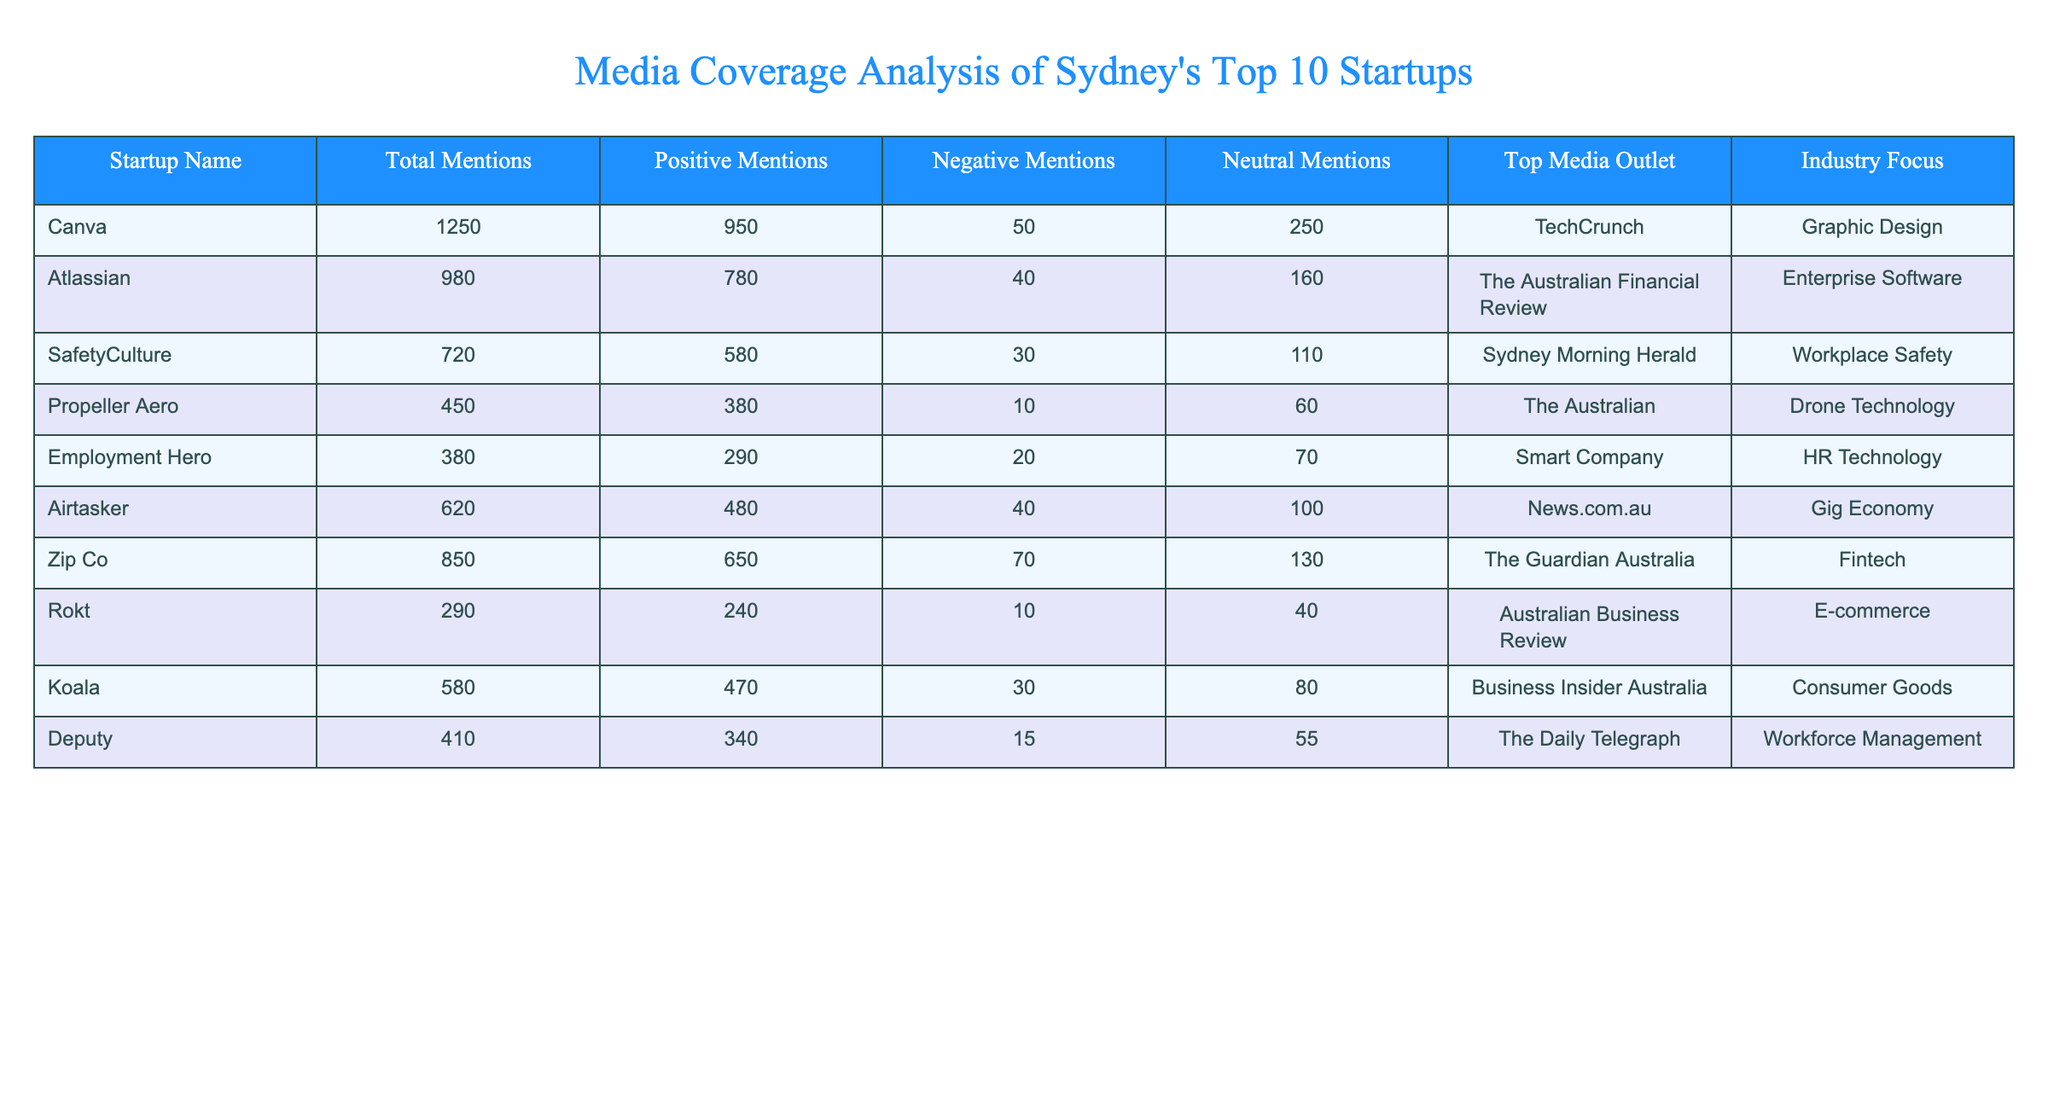What is the total number of mentions for Canva? The table shows that Canva has a total of 1250 mentions listed under the "Total Mentions" column.
Answer: 1250 Which startup has the highest number of positive mentions? By looking at the "Positive Mentions" column, Canva has the highest number at 950, compared to the others.
Answer: Canva What percentage of mentions for Zip Co are positive? The positive mentions for Zip Co are 650 out of a total of 850 mentions, which means (650/850) * 100 = 76.47%.
Answer: 76.47% Is there any startup that has more negative mentions than Deputy? Deputy has 15 negative mentions, and comparing this with other startups, only SafetyCulture (30), Employment Hero (20), Airtasker (40), and Atlassian (40) have more negative mentions. Therefore, yes, there are startups with more negative mentions.
Answer: Yes What is the average number of total mentions for the startups listed in the table? Total mentions for the startups are 1250 + 980 + 720 + 450 + 380 + 620 + 850 + 290 + 580 + 410 =  3,314 mentions; divided by 10 startups gives an average: 3,314 / 10 = 331.4.
Answer: 331.4 How many startups have more than 500 total mentions? From the table, the startups with over 500 mentions are Canva (1250), Atlassian (980), SafetyCulture (720), Airtasker (620), Zip Co (850), and Koala (580). That makes a total of 6 startups.
Answer: 6 What is the difference in total mentions between the startup with the most mentions and the startup with the least mentions? The startup with the most mentions is Canva with 1250, and the one with the least is Rokt with 290. The difference is 1250 - 290 = 960.
Answer: 960 Which media outlet is associated with the startup that has the second highest number of positive mentions? The startup with the second highest positive mentions is Atlassian with 780, and its associated media outlet is The Australian Financial Review.
Answer: The Australian Financial Review What is the proportion of neutral mentions to total mentions for SafetyCulture? SafetyCulture has 110 neutral mentions out of 720 total mentions, which is (110/720) * 100 = 15.28%.
Answer: 15.28% Which startup has the lowest number of mentions and what is its industry focus? Rokt has the lowest number with 290 mentions, and its industry focus is E-commerce.
Answer: Rokt, E-commerce 